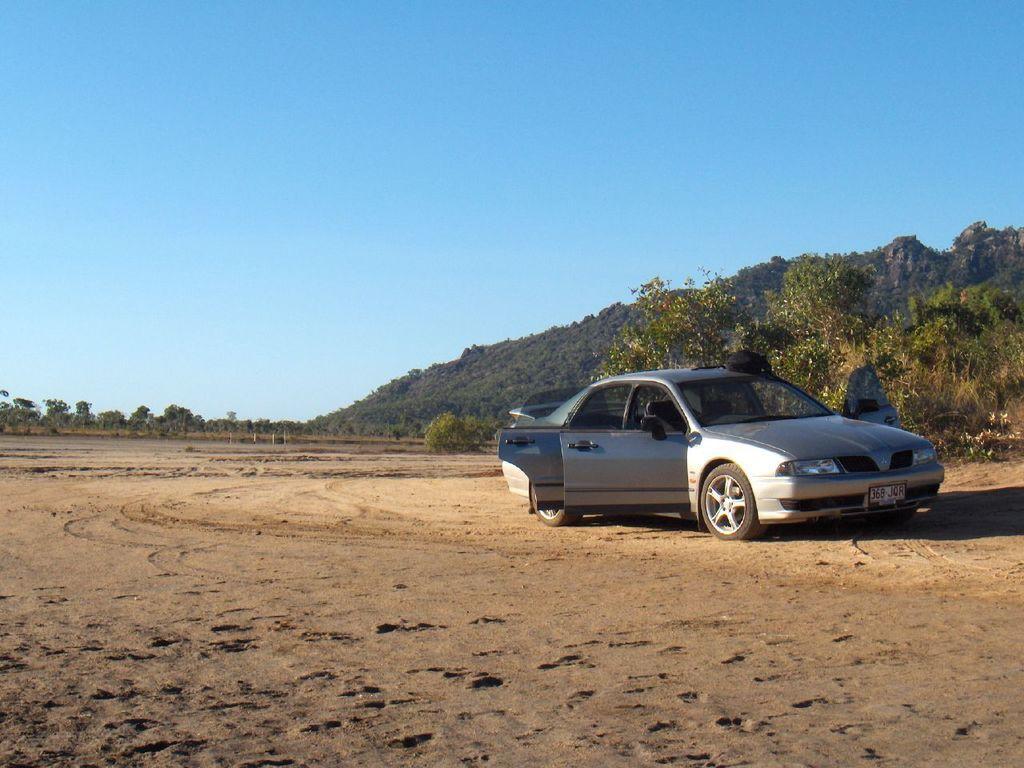Could you give a brief overview of what you see in this image? In this picture we can see a black object on a car. We can see the sand. There are a few plants and trees visible in the background. Sky is blue in color. 